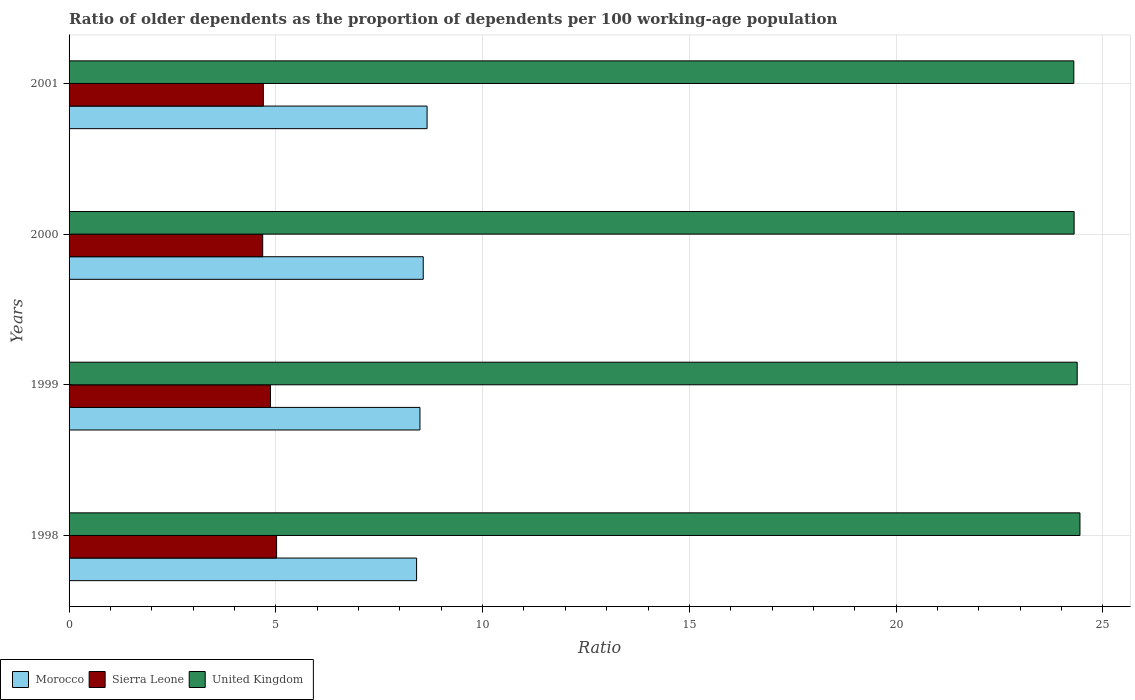How many different coloured bars are there?
Provide a short and direct response. 3. Are the number of bars per tick equal to the number of legend labels?
Offer a very short reply. Yes. Are the number of bars on each tick of the Y-axis equal?
Your answer should be compact. Yes. In how many cases, is the number of bars for a given year not equal to the number of legend labels?
Provide a succinct answer. 0. What is the age dependency ratio(old) in Sierra Leone in 1998?
Your response must be concise. 5.02. Across all years, what is the maximum age dependency ratio(old) in United Kingdom?
Ensure brevity in your answer.  24.44. Across all years, what is the minimum age dependency ratio(old) in Morocco?
Your answer should be compact. 8.4. What is the total age dependency ratio(old) in United Kingdom in the graph?
Provide a short and direct response. 97.42. What is the difference between the age dependency ratio(old) in Sierra Leone in 1998 and that in 1999?
Ensure brevity in your answer.  0.15. What is the difference between the age dependency ratio(old) in United Kingdom in 1998 and the age dependency ratio(old) in Sierra Leone in 1999?
Your response must be concise. 19.57. What is the average age dependency ratio(old) in United Kingdom per year?
Ensure brevity in your answer.  24.36. In the year 2001, what is the difference between the age dependency ratio(old) in Morocco and age dependency ratio(old) in United Kingdom?
Provide a short and direct response. -15.64. In how many years, is the age dependency ratio(old) in Sierra Leone greater than 10 ?
Your answer should be compact. 0. What is the ratio of the age dependency ratio(old) in Morocco in 1999 to that in 2000?
Make the answer very short. 0.99. Is the age dependency ratio(old) in Morocco in 1999 less than that in 2001?
Keep it short and to the point. Yes. Is the difference between the age dependency ratio(old) in Morocco in 1998 and 1999 greater than the difference between the age dependency ratio(old) in United Kingdom in 1998 and 1999?
Offer a very short reply. No. What is the difference between the highest and the second highest age dependency ratio(old) in United Kingdom?
Your answer should be very brief. 0.07. What is the difference between the highest and the lowest age dependency ratio(old) in United Kingdom?
Offer a terse response. 0.15. Is the sum of the age dependency ratio(old) in Sierra Leone in 1998 and 1999 greater than the maximum age dependency ratio(old) in United Kingdom across all years?
Offer a very short reply. No. What does the 2nd bar from the top in 2001 represents?
Keep it short and to the point. Sierra Leone. What does the 2nd bar from the bottom in 2000 represents?
Ensure brevity in your answer.  Sierra Leone. How many years are there in the graph?
Ensure brevity in your answer.  4. Are the values on the major ticks of X-axis written in scientific E-notation?
Your response must be concise. No. Does the graph contain grids?
Ensure brevity in your answer.  Yes. How many legend labels are there?
Keep it short and to the point. 3. How are the legend labels stacked?
Provide a succinct answer. Horizontal. What is the title of the graph?
Your answer should be compact. Ratio of older dependents as the proportion of dependents per 100 working-age population. What is the label or title of the X-axis?
Offer a terse response. Ratio. What is the Ratio in Morocco in 1998?
Ensure brevity in your answer.  8.4. What is the Ratio in Sierra Leone in 1998?
Offer a terse response. 5.02. What is the Ratio of United Kingdom in 1998?
Your response must be concise. 24.44. What is the Ratio of Morocco in 1999?
Provide a succinct answer. 8.48. What is the Ratio in Sierra Leone in 1999?
Offer a very short reply. 4.87. What is the Ratio in United Kingdom in 1999?
Your answer should be compact. 24.38. What is the Ratio in Morocco in 2000?
Offer a very short reply. 8.56. What is the Ratio in Sierra Leone in 2000?
Ensure brevity in your answer.  4.68. What is the Ratio of United Kingdom in 2000?
Your answer should be very brief. 24.3. What is the Ratio of Morocco in 2001?
Ensure brevity in your answer.  8.66. What is the Ratio in Sierra Leone in 2001?
Offer a very short reply. 4.7. What is the Ratio of United Kingdom in 2001?
Make the answer very short. 24.3. Across all years, what is the maximum Ratio of Morocco?
Keep it short and to the point. 8.66. Across all years, what is the maximum Ratio in Sierra Leone?
Give a very brief answer. 5.02. Across all years, what is the maximum Ratio in United Kingdom?
Your response must be concise. 24.44. Across all years, what is the minimum Ratio of Morocco?
Provide a succinct answer. 8.4. Across all years, what is the minimum Ratio in Sierra Leone?
Give a very brief answer. 4.68. Across all years, what is the minimum Ratio in United Kingdom?
Provide a short and direct response. 24.3. What is the total Ratio in Morocco in the graph?
Ensure brevity in your answer.  34.11. What is the total Ratio in Sierra Leone in the graph?
Provide a short and direct response. 19.27. What is the total Ratio of United Kingdom in the graph?
Offer a very short reply. 97.42. What is the difference between the Ratio of Morocco in 1998 and that in 1999?
Make the answer very short. -0.08. What is the difference between the Ratio in Sierra Leone in 1998 and that in 1999?
Provide a succinct answer. 0.15. What is the difference between the Ratio in United Kingdom in 1998 and that in 1999?
Your answer should be very brief. 0.07. What is the difference between the Ratio in Morocco in 1998 and that in 2000?
Provide a succinct answer. -0.16. What is the difference between the Ratio in Sierra Leone in 1998 and that in 2000?
Keep it short and to the point. 0.34. What is the difference between the Ratio of United Kingdom in 1998 and that in 2000?
Keep it short and to the point. 0.14. What is the difference between the Ratio in Morocco in 1998 and that in 2001?
Keep it short and to the point. -0.25. What is the difference between the Ratio of Sierra Leone in 1998 and that in 2001?
Your response must be concise. 0.32. What is the difference between the Ratio of United Kingdom in 1998 and that in 2001?
Provide a short and direct response. 0.15. What is the difference between the Ratio in Morocco in 1999 and that in 2000?
Your answer should be compact. -0.08. What is the difference between the Ratio of Sierra Leone in 1999 and that in 2000?
Your answer should be very brief. 0.19. What is the difference between the Ratio of United Kingdom in 1999 and that in 2000?
Give a very brief answer. 0.07. What is the difference between the Ratio of Morocco in 1999 and that in 2001?
Keep it short and to the point. -0.17. What is the difference between the Ratio of Sierra Leone in 1999 and that in 2001?
Your answer should be very brief. 0.17. What is the difference between the Ratio of United Kingdom in 1999 and that in 2001?
Your response must be concise. 0.08. What is the difference between the Ratio of Morocco in 2000 and that in 2001?
Provide a short and direct response. -0.09. What is the difference between the Ratio of Sierra Leone in 2000 and that in 2001?
Ensure brevity in your answer.  -0.02. What is the difference between the Ratio of United Kingdom in 2000 and that in 2001?
Keep it short and to the point. 0.01. What is the difference between the Ratio in Morocco in 1998 and the Ratio in Sierra Leone in 1999?
Give a very brief answer. 3.53. What is the difference between the Ratio in Morocco in 1998 and the Ratio in United Kingdom in 1999?
Give a very brief answer. -15.97. What is the difference between the Ratio of Sierra Leone in 1998 and the Ratio of United Kingdom in 1999?
Your answer should be very brief. -19.36. What is the difference between the Ratio in Morocco in 1998 and the Ratio in Sierra Leone in 2000?
Give a very brief answer. 3.72. What is the difference between the Ratio of Morocco in 1998 and the Ratio of United Kingdom in 2000?
Offer a terse response. -15.9. What is the difference between the Ratio of Sierra Leone in 1998 and the Ratio of United Kingdom in 2000?
Ensure brevity in your answer.  -19.29. What is the difference between the Ratio in Morocco in 1998 and the Ratio in Sierra Leone in 2001?
Offer a terse response. 3.71. What is the difference between the Ratio of Morocco in 1998 and the Ratio of United Kingdom in 2001?
Offer a very short reply. -15.89. What is the difference between the Ratio in Sierra Leone in 1998 and the Ratio in United Kingdom in 2001?
Provide a succinct answer. -19.28. What is the difference between the Ratio of Morocco in 1999 and the Ratio of Sierra Leone in 2000?
Make the answer very short. 3.8. What is the difference between the Ratio of Morocco in 1999 and the Ratio of United Kingdom in 2000?
Your answer should be very brief. -15.82. What is the difference between the Ratio in Sierra Leone in 1999 and the Ratio in United Kingdom in 2000?
Your answer should be very brief. -19.43. What is the difference between the Ratio in Morocco in 1999 and the Ratio in Sierra Leone in 2001?
Your response must be concise. 3.79. What is the difference between the Ratio in Morocco in 1999 and the Ratio in United Kingdom in 2001?
Give a very brief answer. -15.81. What is the difference between the Ratio in Sierra Leone in 1999 and the Ratio in United Kingdom in 2001?
Provide a succinct answer. -19.43. What is the difference between the Ratio of Morocco in 2000 and the Ratio of Sierra Leone in 2001?
Offer a terse response. 3.87. What is the difference between the Ratio in Morocco in 2000 and the Ratio in United Kingdom in 2001?
Give a very brief answer. -15.73. What is the difference between the Ratio in Sierra Leone in 2000 and the Ratio in United Kingdom in 2001?
Provide a short and direct response. -19.61. What is the average Ratio of Morocco per year?
Ensure brevity in your answer.  8.53. What is the average Ratio in Sierra Leone per year?
Ensure brevity in your answer.  4.82. What is the average Ratio of United Kingdom per year?
Your answer should be compact. 24.36. In the year 1998, what is the difference between the Ratio of Morocco and Ratio of Sierra Leone?
Ensure brevity in your answer.  3.39. In the year 1998, what is the difference between the Ratio of Morocco and Ratio of United Kingdom?
Your answer should be compact. -16.04. In the year 1998, what is the difference between the Ratio in Sierra Leone and Ratio in United Kingdom?
Your response must be concise. -19.43. In the year 1999, what is the difference between the Ratio in Morocco and Ratio in Sierra Leone?
Keep it short and to the point. 3.61. In the year 1999, what is the difference between the Ratio of Morocco and Ratio of United Kingdom?
Ensure brevity in your answer.  -15.89. In the year 1999, what is the difference between the Ratio of Sierra Leone and Ratio of United Kingdom?
Ensure brevity in your answer.  -19.51. In the year 2000, what is the difference between the Ratio in Morocco and Ratio in Sierra Leone?
Keep it short and to the point. 3.88. In the year 2000, what is the difference between the Ratio in Morocco and Ratio in United Kingdom?
Your answer should be very brief. -15.74. In the year 2000, what is the difference between the Ratio in Sierra Leone and Ratio in United Kingdom?
Offer a very short reply. -19.62. In the year 2001, what is the difference between the Ratio in Morocco and Ratio in Sierra Leone?
Make the answer very short. 3.96. In the year 2001, what is the difference between the Ratio in Morocco and Ratio in United Kingdom?
Provide a short and direct response. -15.64. In the year 2001, what is the difference between the Ratio of Sierra Leone and Ratio of United Kingdom?
Give a very brief answer. -19.6. What is the ratio of the Ratio of Sierra Leone in 1998 to that in 1999?
Your response must be concise. 1.03. What is the ratio of the Ratio of Morocco in 1998 to that in 2000?
Make the answer very short. 0.98. What is the ratio of the Ratio of Sierra Leone in 1998 to that in 2000?
Give a very brief answer. 1.07. What is the ratio of the Ratio of Morocco in 1998 to that in 2001?
Your response must be concise. 0.97. What is the ratio of the Ratio in Sierra Leone in 1998 to that in 2001?
Make the answer very short. 1.07. What is the ratio of the Ratio in United Kingdom in 1998 to that in 2001?
Offer a terse response. 1.01. What is the ratio of the Ratio of Morocco in 1999 to that in 2000?
Keep it short and to the point. 0.99. What is the ratio of the Ratio of Sierra Leone in 1999 to that in 2000?
Your response must be concise. 1.04. What is the ratio of the Ratio of United Kingdom in 1999 to that in 2000?
Provide a succinct answer. 1. What is the ratio of the Ratio of Morocco in 1999 to that in 2001?
Keep it short and to the point. 0.98. What is the ratio of the Ratio in Sierra Leone in 1999 to that in 2001?
Provide a succinct answer. 1.04. What is the ratio of the Ratio of Morocco in 2000 to that in 2001?
Your response must be concise. 0.99. What is the ratio of the Ratio in Sierra Leone in 2000 to that in 2001?
Your answer should be very brief. 1. What is the ratio of the Ratio in United Kingdom in 2000 to that in 2001?
Your answer should be very brief. 1. What is the difference between the highest and the second highest Ratio in Morocco?
Make the answer very short. 0.09. What is the difference between the highest and the second highest Ratio in Sierra Leone?
Your response must be concise. 0.15. What is the difference between the highest and the second highest Ratio in United Kingdom?
Offer a very short reply. 0.07. What is the difference between the highest and the lowest Ratio in Morocco?
Offer a terse response. 0.25. What is the difference between the highest and the lowest Ratio of Sierra Leone?
Provide a succinct answer. 0.34. What is the difference between the highest and the lowest Ratio of United Kingdom?
Your answer should be very brief. 0.15. 